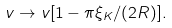Convert formula to latex. <formula><loc_0><loc_0><loc_500><loc_500>v \to v [ 1 - \pi \xi _ { K } / ( 2 R ) ] .</formula> 